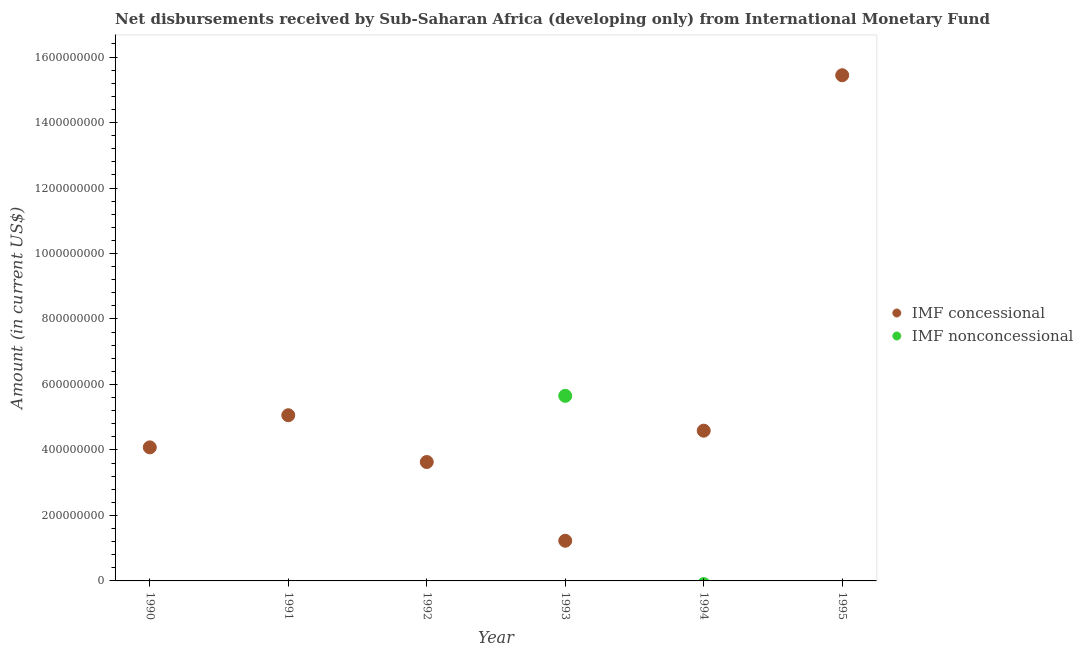What is the net concessional disbursements from imf in 1995?
Provide a succinct answer. 1.54e+09. Across all years, what is the maximum net non concessional disbursements from imf?
Offer a very short reply. 5.65e+08. Across all years, what is the minimum net non concessional disbursements from imf?
Provide a succinct answer. 0. What is the total net concessional disbursements from imf in the graph?
Make the answer very short. 3.40e+09. What is the difference between the net concessional disbursements from imf in 1990 and that in 1994?
Give a very brief answer. -5.10e+07. What is the difference between the net concessional disbursements from imf in 1990 and the net non concessional disbursements from imf in 1993?
Provide a succinct answer. -1.57e+08. What is the average net non concessional disbursements from imf per year?
Make the answer very short. 9.42e+07. In the year 1993, what is the difference between the net non concessional disbursements from imf and net concessional disbursements from imf?
Give a very brief answer. 4.43e+08. In how many years, is the net non concessional disbursements from imf greater than 760000000 US$?
Your response must be concise. 0. What is the ratio of the net concessional disbursements from imf in 1991 to that in 1993?
Ensure brevity in your answer.  4.13. Is the net concessional disbursements from imf in 1993 less than that in 1995?
Ensure brevity in your answer.  Yes. What is the difference between the highest and the second highest net concessional disbursements from imf?
Offer a very short reply. 1.04e+09. What is the difference between the highest and the lowest net non concessional disbursements from imf?
Give a very brief answer. 5.65e+08. Is the sum of the net concessional disbursements from imf in 1991 and 1994 greater than the maximum net non concessional disbursements from imf across all years?
Offer a very short reply. Yes. Does the net non concessional disbursements from imf monotonically increase over the years?
Offer a very short reply. No. How many dotlines are there?
Provide a succinct answer. 2. How many years are there in the graph?
Your answer should be compact. 6. Are the values on the major ticks of Y-axis written in scientific E-notation?
Provide a succinct answer. No. Does the graph contain grids?
Your answer should be compact. No. What is the title of the graph?
Give a very brief answer. Net disbursements received by Sub-Saharan Africa (developing only) from International Monetary Fund. What is the label or title of the X-axis?
Offer a terse response. Year. What is the Amount (in current US$) of IMF concessional in 1990?
Your answer should be compact. 4.08e+08. What is the Amount (in current US$) in IMF concessional in 1991?
Provide a succinct answer. 5.06e+08. What is the Amount (in current US$) in IMF concessional in 1992?
Offer a terse response. 3.63e+08. What is the Amount (in current US$) in IMF nonconcessional in 1992?
Your answer should be compact. 0. What is the Amount (in current US$) in IMF concessional in 1993?
Keep it short and to the point. 1.23e+08. What is the Amount (in current US$) in IMF nonconcessional in 1993?
Offer a terse response. 5.65e+08. What is the Amount (in current US$) of IMF concessional in 1994?
Offer a terse response. 4.59e+08. What is the Amount (in current US$) of IMF nonconcessional in 1994?
Ensure brevity in your answer.  0. What is the Amount (in current US$) in IMF concessional in 1995?
Provide a short and direct response. 1.54e+09. Across all years, what is the maximum Amount (in current US$) of IMF concessional?
Your answer should be compact. 1.54e+09. Across all years, what is the maximum Amount (in current US$) in IMF nonconcessional?
Your answer should be compact. 5.65e+08. Across all years, what is the minimum Amount (in current US$) in IMF concessional?
Your answer should be compact. 1.23e+08. What is the total Amount (in current US$) of IMF concessional in the graph?
Offer a terse response. 3.40e+09. What is the total Amount (in current US$) in IMF nonconcessional in the graph?
Make the answer very short. 5.65e+08. What is the difference between the Amount (in current US$) of IMF concessional in 1990 and that in 1991?
Keep it short and to the point. -9.81e+07. What is the difference between the Amount (in current US$) of IMF concessional in 1990 and that in 1992?
Your answer should be very brief. 4.48e+07. What is the difference between the Amount (in current US$) of IMF concessional in 1990 and that in 1993?
Provide a short and direct response. 2.85e+08. What is the difference between the Amount (in current US$) of IMF concessional in 1990 and that in 1994?
Ensure brevity in your answer.  -5.10e+07. What is the difference between the Amount (in current US$) in IMF concessional in 1990 and that in 1995?
Keep it short and to the point. -1.14e+09. What is the difference between the Amount (in current US$) in IMF concessional in 1991 and that in 1992?
Ensure brevity in your answer.  1.43e+08. What is the difference between the Amount (in current US$) in IMF concessional in 1991 and that in 1993?
Your answer should be compact. 3.83e+08. What is the difference between the Amount (in current US$) in IMF concessional in 1991 and that in 1994?
Make the answer very short. 4.72e+07. What is the difference between the Amount (in current US$) of IMF concessional in 1991 and that in 1995?
Provide a short and direct response. -1.04e+09. What is the difference between the Amount (in current US$) in IMF concessional in 1992 and that in 1993?
Offer a very short reply. 2.40e+08. What is the difference between the Amount (in current US$) in IMF concessional in 1992 and that in 1994?
Keep it short and to the point. -9.57e+07. What is the difference between the Amount (in current US$) of IMF concessional in 1992 and that in 1995?
Ensure brevity in your answer.  -1.18e+09. What is the difference between the Amount (in current US$) of IMF concessional in 1993 and that in 1994?
Make the answer very short. -3.36e+08. What is the difference between the Amount (in current US$) of IMF concessional in 1993 and that in 1995?
Your response must be concise. -1.42e+09. What is the difference between the Amount (in current US$) of IMF concessional in 1994 and that in 1995?
Your answer should be compact. -1.09e+09. What is the difference between the Amount (in current US$) of IMF concessional in 1990 and the Amount (in current US$) of IMF nonconcessional in 1993?
Your answer should be very brief. -1.57e+08. What is the difference between the Amount (in current US$) of IMF concessional in 1991 and the Amount (in current US$) of IMF nonconcessional in 1993?
Provide a short and direct response. -5.92e+07. What is the difference between the Amount (in current US$) of IMF concessional in 1992 and the Amount (in current US$) of IMF nonconcessional in 1993?
Ensure brevity in your answer.  -2.02e+08. What is the average Amount (in current US$) of IMF concessional per year?
Give a very brief answer. 5.67e+08. What is the average Amount (in current US$) in IMF nonconcessional per year?
Make the answer very short. 9.42e+07. In the year 1993, what is the difference between the Amount (in current US$) of IMF concessional and Amount (in current US$) of IMF nonconcessional?
Give a very brief answer. -4.43e+08. What is the ratio of the Amount (in current US$) in IMF concessional in 1990 to that in 1991?
Offer a terse response. 0.81. What is the ratio of the Amount (in current US$) of IMF concessional in 1990 to that in 1992?
Offer a terse response. 1.12. What is the ratio of the Amount (in current US$) in IMF concessional in 1990 to that in 1993?
Your answer should be compact. 3.33. What is the ratio of the Amount (in current US$) in IMF concessional in 1990 to that in 1995?
Give a very brief answer. 0.26. What is the ratio of the Amount (in current US$) in IMF concessional in 1991 to that in 1992?
Ensure brevity in your answer.  1.39. What is the ratio of the Amount (in current US$) of IMF concessional in 1991 to that in 1993?
Your answer should be compact. 4.13. What is the ratio of the Amount (in current US$) in IMF concessional in 1991 to that in 1994?
Your response must be concise. 1.1. What is the ratio of the Amount (in current US$) of IMF concessional in 1991 to that in 1995?
Provide a succinct answer. 0.33. What is the ratio of the Amount (in current US$) of IMF concessional in 1992 to that in 1993?
Provide a short and direct response. 2.96. What is the ratio of the Amount (in current US$) in IMF concessional in 1992 to that in 1994?
Offer a very short reply. 0.79. What is the ratio of the Amount (in current US$) of IMF concessional in 1992 to that in 1995?
Your response must be concise. 0.24. What is the ratio of the Amount (in current US$) of IMF concessional in 1993 to that in 1994?
Offer a very short reply. 0.27. What is the ratio of the Amount (in current US$) in IMF concessional in 1993 to that in 1995?
Provide a succinct answer. 0.08. What is the ratio of the Amount (in current US$) of IMF concessional in 1994 to that in 1995?
Provide a short and direct response. 0.3. What is the difference between the highest and the second highest Amount (in current US$) in IMF concessional?
Offer a terse response. 1.04e+09. What is the difference between the highest and the lowest Amount (in current US$) of IMF concessional?
Keep it short and to the point. 1.42e+09. What is the difference between the highest and the lowest Amount (in current US$) of IMF nonconcessional?
Offer a terse response. 5.65e+08. 